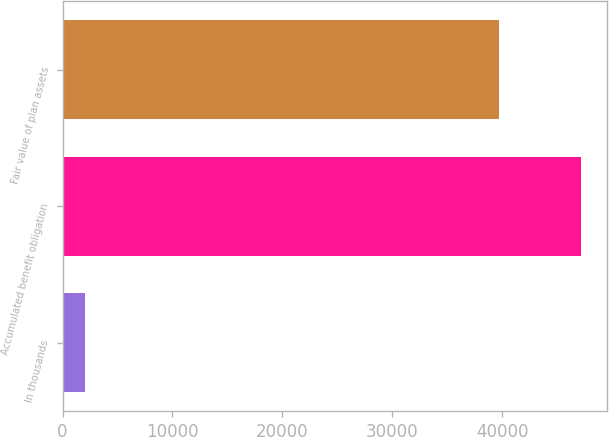Convert chart. <chart><loc_0><loc_0><loc_500><loc_500><bar_chart><fcel>In thousands<fcel>Accumulated benefit obligation<fcel>Fair value of plan assets<nl><fcel>2010<fcel>47217<fcel>39738<nl></chart> 